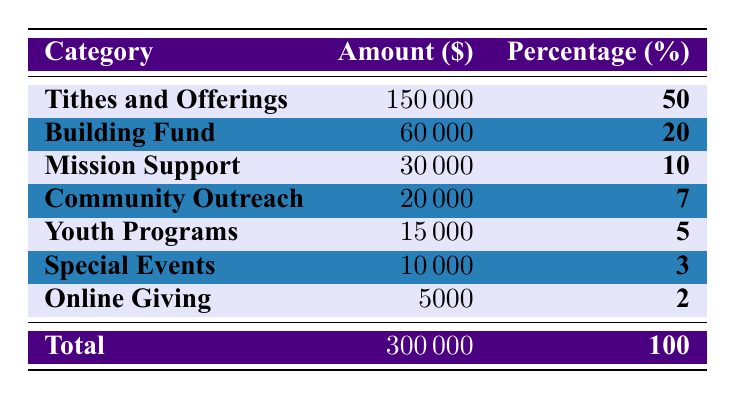What was the total amount of donations received by the church in 2022? The total amount is stated in the last row of the table as 300,000.
Answer: 300,000 What percentage of total donations came from Tithes and Offerings? The table shows that Tithes and Offerings contributed 50% of the total donations.
Answer: 50% How much did the church receive from the Building Fund? The Building Fund amount is listed directly in the table as 60,000.
Answer: 60,000 What is the difference in amount between Mission Support and Community Outreach? The amounts are 30,000 for Mission Support and 20,000 for Community Outreach. The difference is calculated as 30,000 - 20,000 = 10,000.
Answer: 10,000 What was the total percentage of donations from Youth Programs and Special Events combined? The percentages are 5% for Youth Programs and 3% for Special Events; summing these gives 5% + 3% = 8%.
Answer: 8% Is the amount of money received from Online Giving greater than 10,000? The table lists Online Giving as 5,000, which is less than 10,000. Hence, the answer is no.
Answer: No What was the amount received from the Mission Support category compared to the Combined total of Community Outreach, Youth Programs, Special Events, and Online Giving? The sum of Community Outreach (20,000), Youth Programs (15,000), Special Events (10,000), and Online Giving (5,000) is 50,000, while Mission Support is 30,000. Since 30,000 is less than 50,000, the answer is confirmed.
Answer: No What percentage of the total donations did the Youth Programs category account for compared to the total? The Youth Programs amount is 15,000 and its percentage is 5% out of 300,000, which is indeed accurate as (15,000/300,000) * 100 = 5%.
Answer: Yes Which category received the least amount of donations? By examining the amounts listed, Online Giving received 5,000, which is the lowest amount in the table.
Answer: Online Giving If you were to rank the categories by the amount received, which category would rank third? The amounts from the highest to lowest are: Tithes and Offerings (150,000), Building Fund (60,000), and Mission Support (30,000), making Mission Support the third category.
Answer: Mission Support 